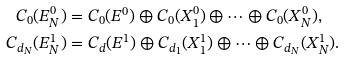<formula> <loc_0><loc_0><loc_500><loc_500>C _ { 0 } ( E _ { N } ^ { 0 } ) & = C _ { 0 } ( E ^ { 0 } ) \oplus C _ { 0 } ( X _ { 1 } ^ { 0 } ) \oplus \cdots \oplus C _ { 0 } ( X _ { N } ^ { 0 } ) , \\ C _ { d _ { N } } ( E _ { N } ^ { 1 } ) & = C _ { d } ( E ^ { 1 } ) \oplus C _ { d _ { 1 } } ( X _ { 1 } ^ { 1 } ) \oplus \cdots \oplus C _ { d _ { N } } ( X _ { N } ^ { 1 } ) .</formula> 